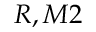<formula> <loc_0><loc_0><loc_500><loc_500>R , M 2</formula> 